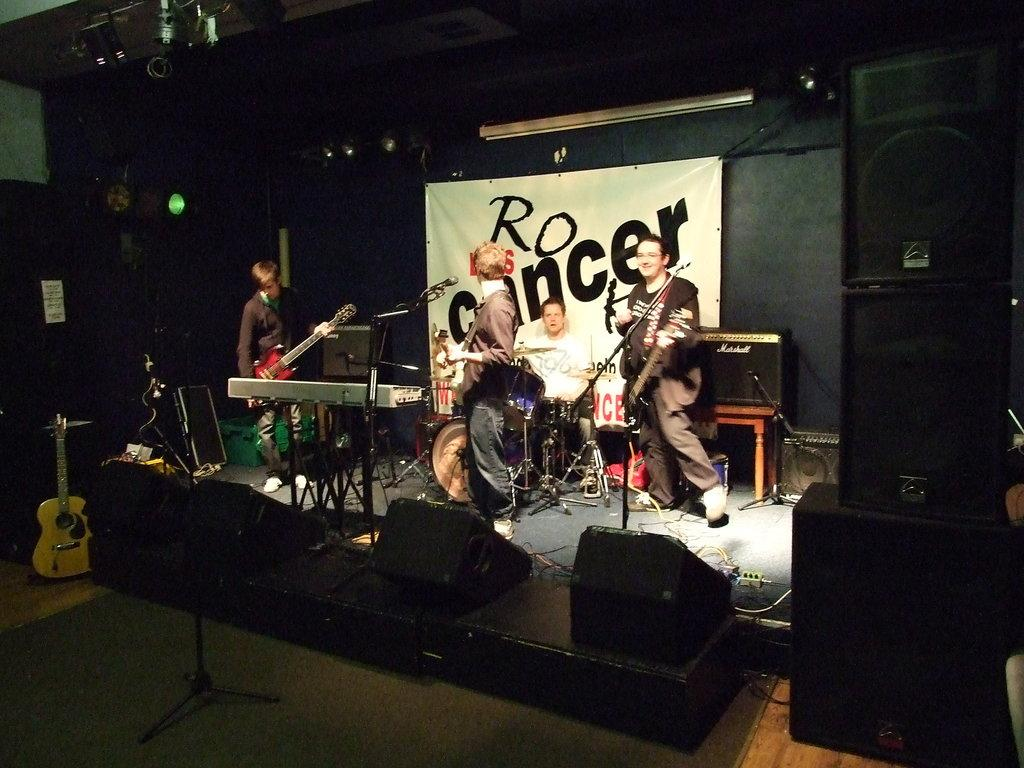What is the main setting of the image? The image depicts a stage. What can be seen on the stage besides the people? There are multiple speakers and musical instruments on the stage. How many people are playing musical instruments on the stage? Four people are playing musical instruments on the stage. What is visible in the background of the stage? There is a banner in the background of the stage. How many oranges are being used as percussion instruments on the stage? There are no oranges present on the stage; the image features musical instruments such as speakers and various unspecified instruments. 